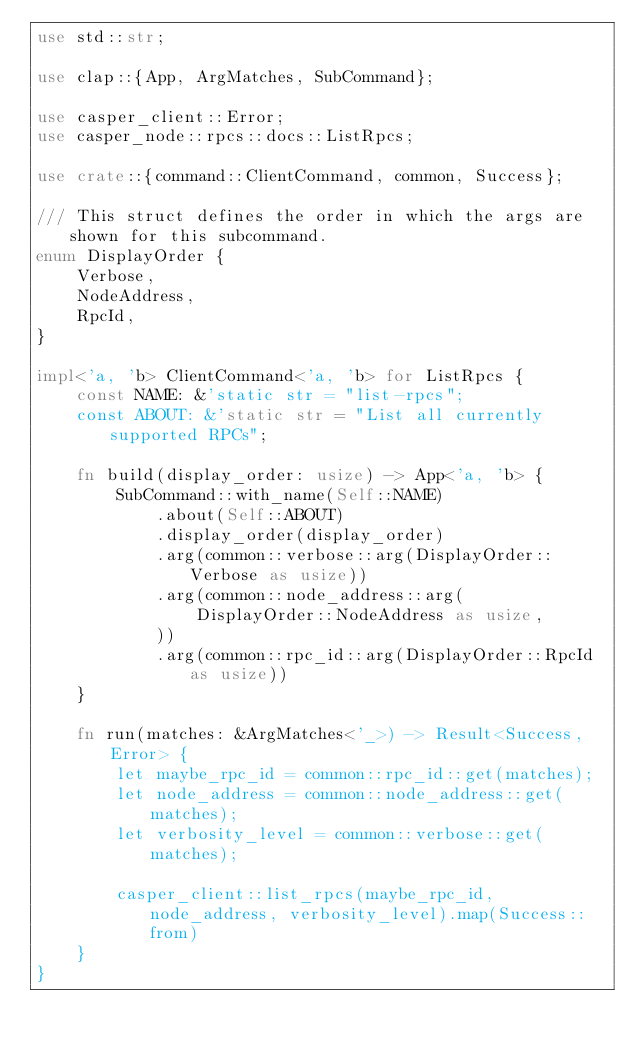Convert code to text. <code><loc_0><loc_0><loc_500><loc_500><_Rust_>use std::str;

use clap::{App, ArgMatches, SubCommand};

use casper_client::Error;
use casper_node::rpcs::docs::ListRpcs;

use crate::{command::ClientCommand, common, Success};

/// This struct defines the order in which the args are shown for this subcommand.
enum DisplayOrder {
    Verbose,
    NodeAddress,
    RpcId,
}

impl<'a, 'b> ClientCommand<'a, 'b> for ListRpcs {
    const NAME: &'static str = "list-rpcs";
    const ABOUT: &'static str = "List all currently supported RPCs";

    fn build(display_order: usize) -> App<'a, 'b> {
        SubCommand::with_name(Self::NAME)
            .about(Self::ABOUT)
            .display_order(display_order)
            .arg(common::verbose::arg(DisplayOrder::Verbose as usize))
            .arg(common::node_address::arg(
                DisplayOrder::NodeAddress as usize,
            ))
            .arg(common::rpc_id::arg(DisplayOrder::RpcId as usize))
    }

    fn run(matches: &ArgMatches<'_>) -> Result<Success, Error> {
        let maybe_rpc_id = common::rpc_id::get(matches);
        let node_address = common::node_address::get(matches);
        let verbosity_level = common::verbose::get(matches);

        casper_client::list_rpcs(maybe_rpc_id, node_address, verbosity_level).map(Success::from)
    }
}
</code> 